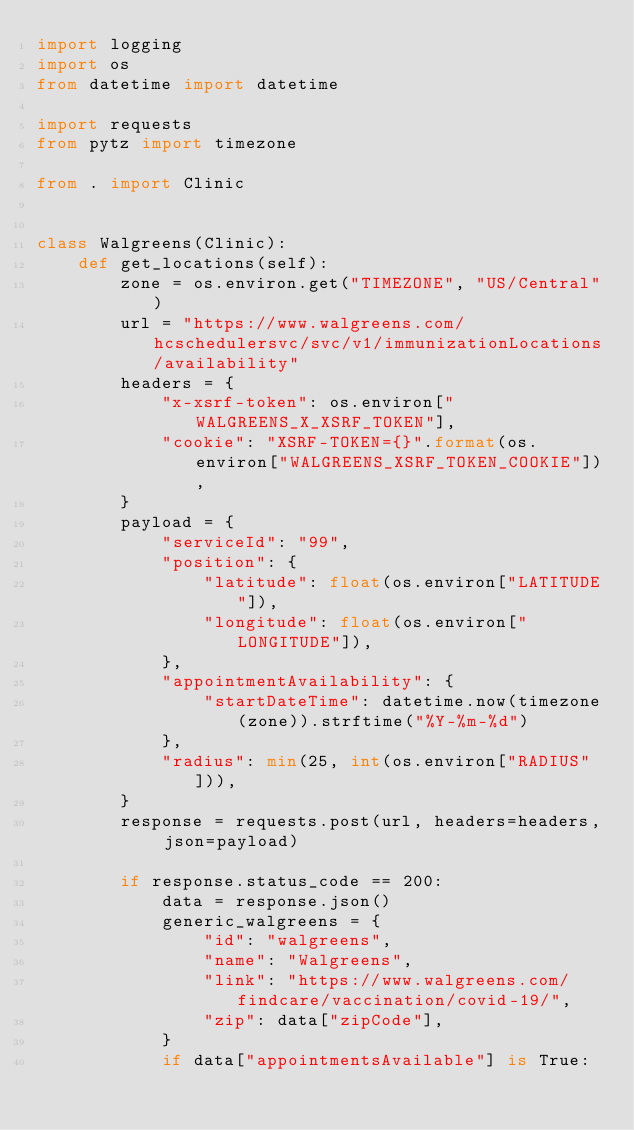Convert code to text. <code><loc_0><loc_0><loc_500><loc_500><_Python_>import logging
import os
from datetime import datetime

import requests
from pytz import timezone

from . import Clinic


class Walgreens(Clinic):
    def get_locations(self):
        zone = os.environ.get("TIMEZONE", "US/Central")
        url = "https://www.walgreens.com/hcschedulersvc/svc/v1/immunizationLocations/availability"
        headers = {
            "x-xsrf-token": os.environ["WALGREENS_X_XSRF_TOKEN"],
            "cookie": "XSRF-TOKEN={}".format(os.environ["WALGREENS_XSRF_TOKEN_COOKIE"]),
        }
        payload = {
            "serviceId": "99",
            "position": {
                "latitude": float(os.environ["LATITUDE"]),
                "longitude": float(os.environ["LONGITUDE"]),
            },
            "appointmentAvailability": {
                "startDateTime": datetime.now(timezone(zone)).strftime("%Y-%m-%d")
            },
            "radius": min(25, int(os.environ["RADIUS"])),
        }
        response = requests.post(url, headers=headers, json=payload)

        if response.status_code == 200:
            data = response.json()
            generic_walgreens = {
                "id": "walgreens",
                "name": "Walgreens",
                "link": "https://www.walgreens.com/findcare/vaccination/covid-19/",
                "zip": data["zipCode"],
            }
            if data["appointmentsAvailable"] is True:</code> 